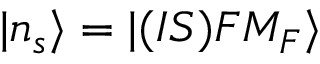Convert formula to latex. <formula><loc_0><loc_0><loc_500><loc_500>| n _ { s } \rangle = | ( I S ) F M _ { F } \rangle</formula> 